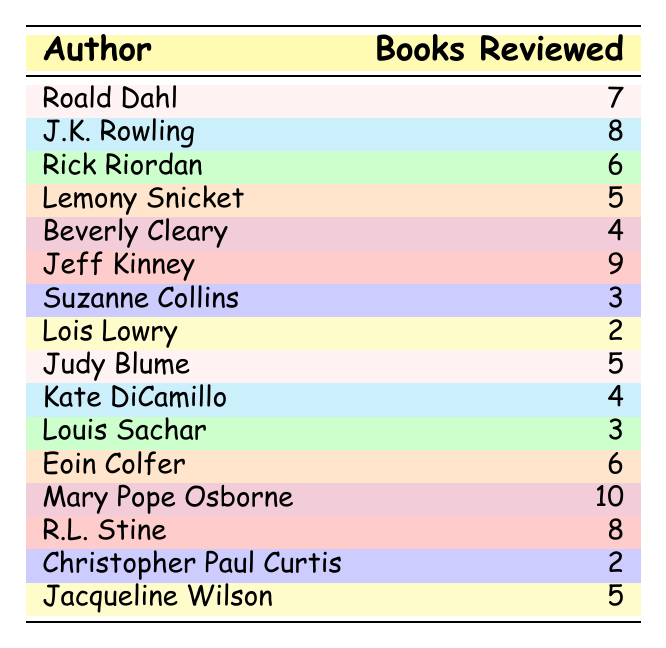What is the name of the author with the most books reviewed? By looking at the table, I can identify that Mary Pope Osborne has the highest number of books reviewed, which is 10.
Answer: Mary Pope Osborne How many books have I reviewed by Jeff Kinney? The table shows that I have reviewed 9 books by Jeff Kinney.
Answer: 9 Which author has the least number of books reviewed? The least number of books reviewed is 2, and it belongs to both Lois Lowry and Christopher Paul Curtis.
Answer: Lois Lowry and Christopher Paul Curtis What is the total number of books reviewed for all the authors listed? To find the total, I need to sum all the books reviewed: 7 + 8 + 6 + 5 + 4 + 9 + 3 + 2 + 5 + 4 + 3 + 6 + 10 + 8 + 2 + 5 = 81.
Answer: 81 Is it true that I reviewed more books by J.K. Rowling than by Rick Riordan? Yes, according to the table, I have reviewed 8 books by J.K. Rowling and only 6 by Rick Riordan, which means it's true.
Answer: Yes What is the average number of books reviewed per author? There are 16 authors listed, and the total number of books reviewed is 81. To find the average, I divide 81 by 16, which equals 5.0625. Rounding this gives approximately 5.06.
Answer: 5.06 Which two authors have the same number of books reviewed? The table indicates that both Beverly Cleary and Kate DiCamillo have 4 books reviewed, as well as Jacqueline Wilson and Lemony Snicket, who both have 5 books reviewed.
Answer: Beverly Cleary and Kate DiCamillo, Jacqueline Wilson and Lemony Snicket How many more books did I review by Jeff Kinney compared to Suzanne Collins? Jeff Kinney has 9 books reviewed and Suzanne Collins has 3, so subtracting gives 9 - 3 = 6 more books reviewed.
Answer: 6 Are there more authors with 5 or more books reviewed than those with fewer than 5? Counting the authors, we have 9 authors who have reviewed 5 or more books (Mary Pope Osborne, Jeff Kinney, J.K. Rowling, R.L. Stine, Roald Dahl, Eoin Colfer, Rick Riordan, Jacqueline Wilson, and Lemony Snicket) compared to 7 authors with fewer than 5 (Suzanne Collins, Lois Lowry, Christopher Paul Curtis, Beverly Cleary, Kate DiCamillo, and Louis Sachar). Therefore, there are more authors with 5 or more books reviewed.
Answer: Yes What is the difference in the number of books reviewed between Mary Pope Osborne and Lois Lowry? Mary Pope Osborne has reviewed 10 books while Lois Lowry has reviewed 2 books, so the difference is 10 - 2 = 8.
Answer: 8 